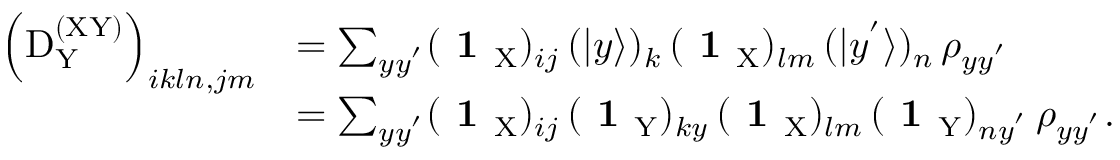Convert formula to latex. <formula><loc_0><loc_0><loc_500><loc_500>\begin{array} { r l } { \left ( D _ { \mathrm Y } ^ { ( X Y ) } \right ) _ { i k \ln , j m } } & { = \sum _ { y y ^ { ^ { \prime } } } ( 1 _ { X } ) _ { i j } \, ( | y \rangle ) _ { k } \, ( 1 _ { X } ) _ { l m } \, ( | y ^ { ^ { \prime } } \rangle ) _ { n } \, \rho _ { y y ^ { ^ { \prime } } } } \\ & { = \sum _ { y y ^ { ^ { \prime } } } ( 1 _ { X } ) _ { i j } \, ( 1 _ { Y } ) _ { k y } \, ( 1 _ { X } ) _ { l m } \, ( 1 _ { Y } ) _ { n y ^ { ^ { \prime } } } \, \rho _ { y y ^ { ^ { \prime } } } . } \end{array}</formula> 